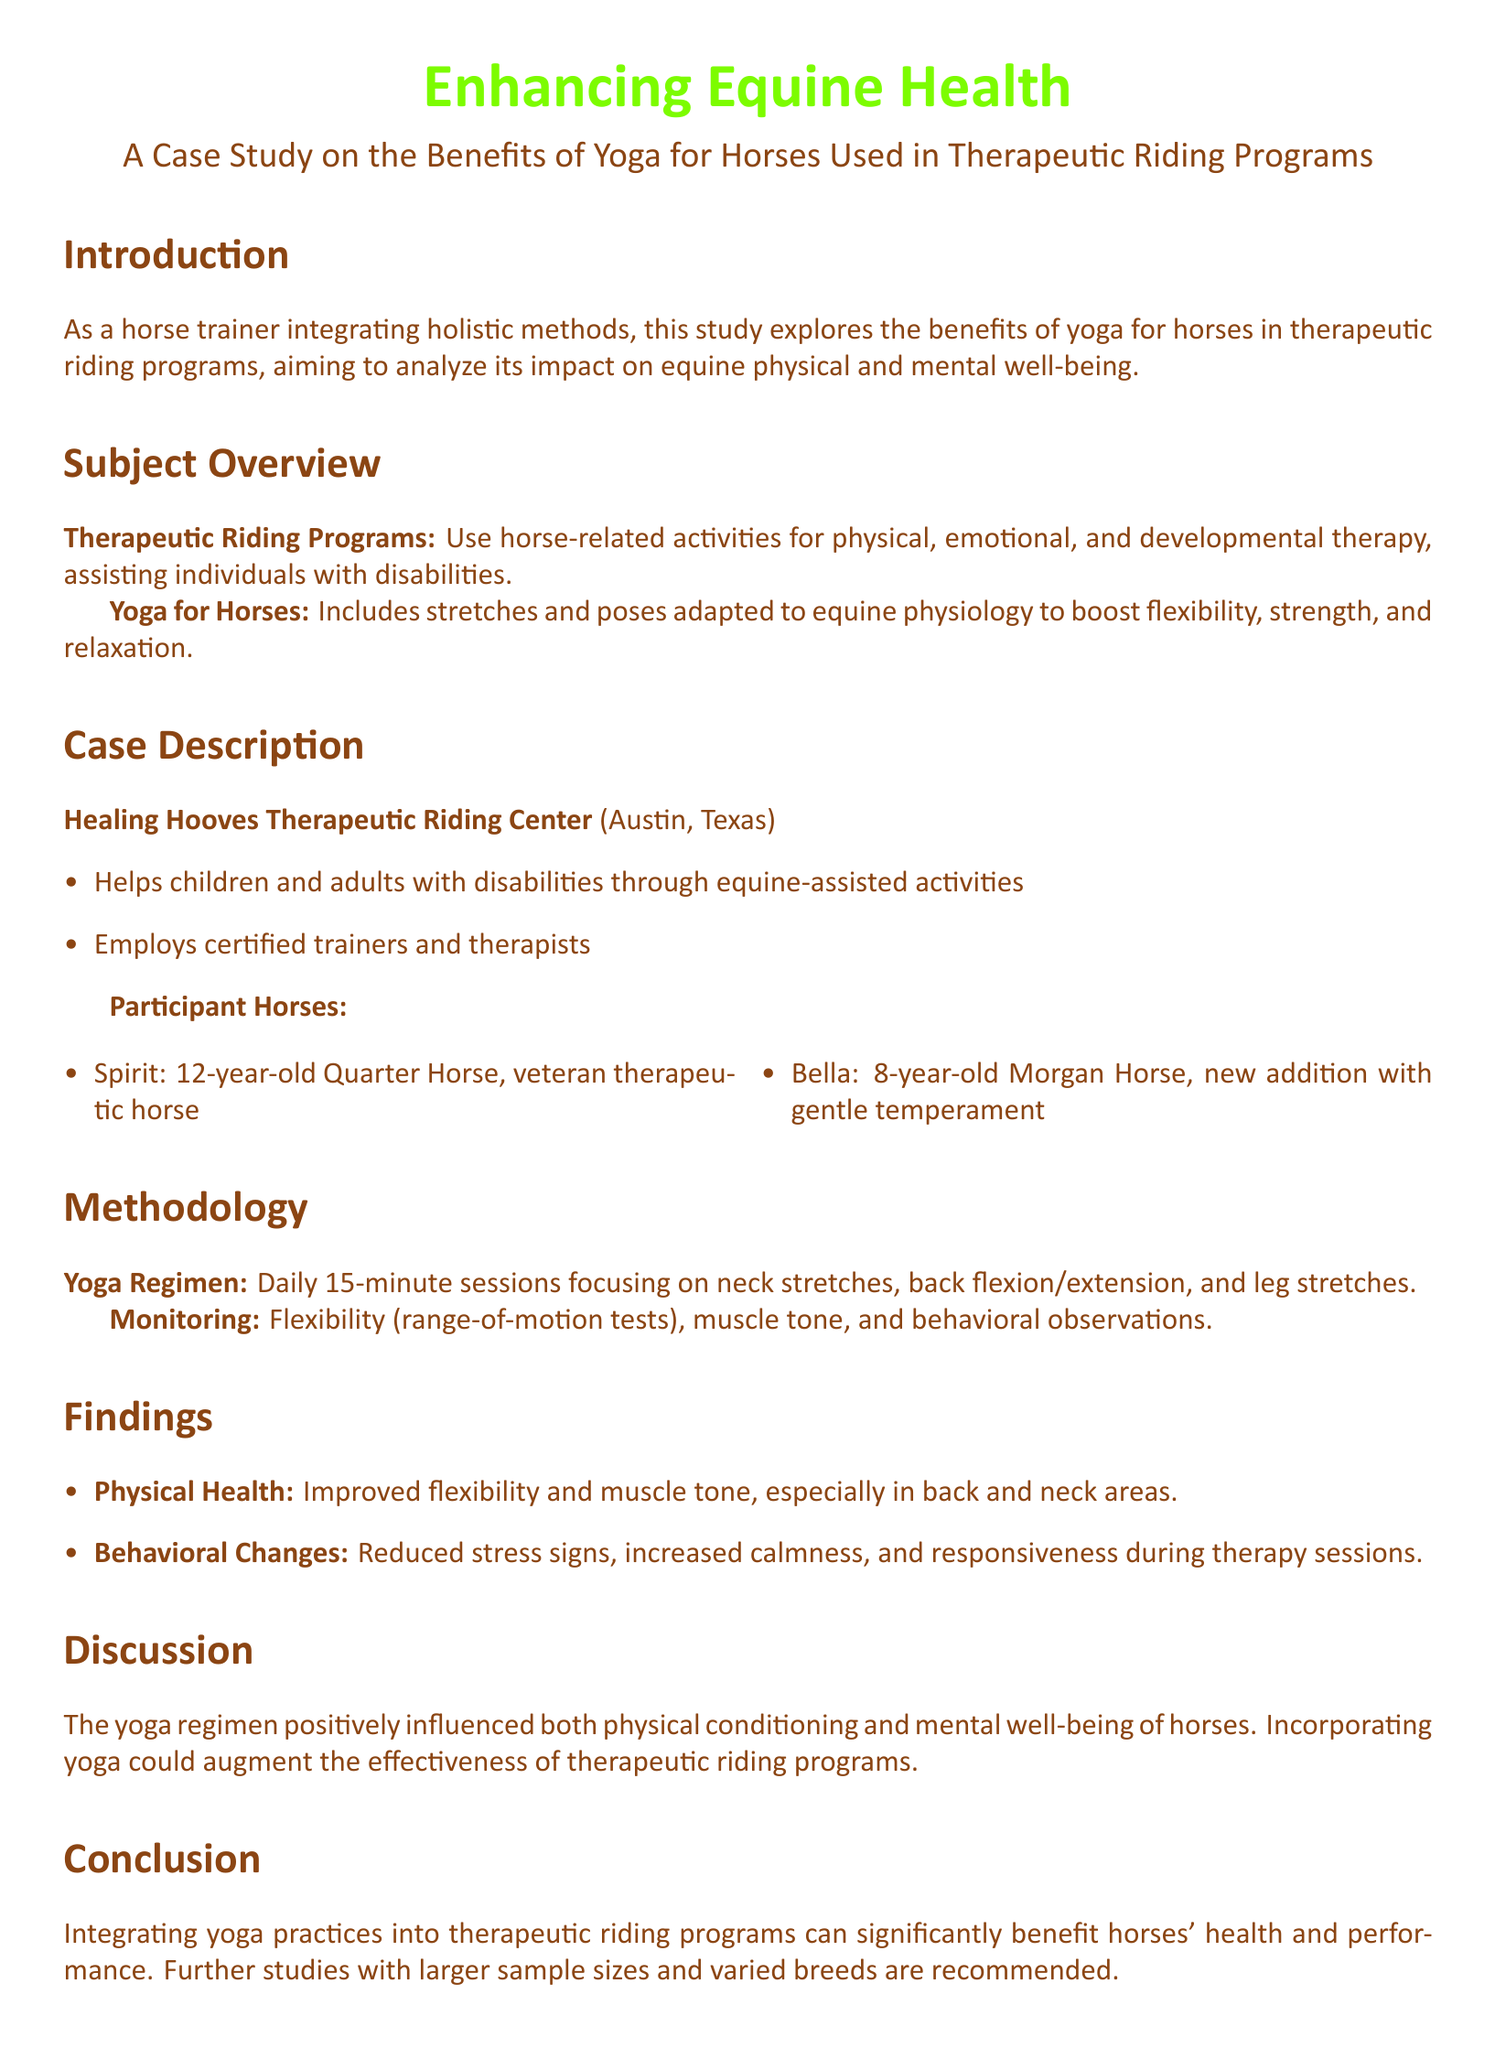What is the title of the case study? The title of the case study is presented prominently in the document.
Answer: Enhancing Equine Health: A Case Study on the Benefits of Yoga for Horses Used in Therapeutic Riding Programs Which therapeutic riding center is mentioned in the case study? The document specifies the name of the therapeutic riding center as part of the case description.
Answer: Healing Hooves Therapeutic Riding Center How long are the daily yoga sessions for the horses? The duration of the yoga regimen is noted in the methodology section.
Answer: 15 minutes What are the names of the participant horses? The case description lists the horses' names involved in the study.
Answer: Spirit, Bella What improvements were observed in the horses' physical health? The findings section details the specific physical health improvements noted during the study.
Answer: Improved flexibility and muscle tone What type of changes were observed in the horses' behavior? Behavioral changes are summarized in the findings section as part of the observations made during the study.
Answer: Reduced stress signs, increased calmness What could augment the effectiveness of therapeutic riding programs? The discussion highlights an important point about enhancing these programs.
Answer: Incorporating yoga What is the recommendation for further studies? The conclusion section contains recommendations regarding future research.
Answer: Larger sample sizes and varied breeds 